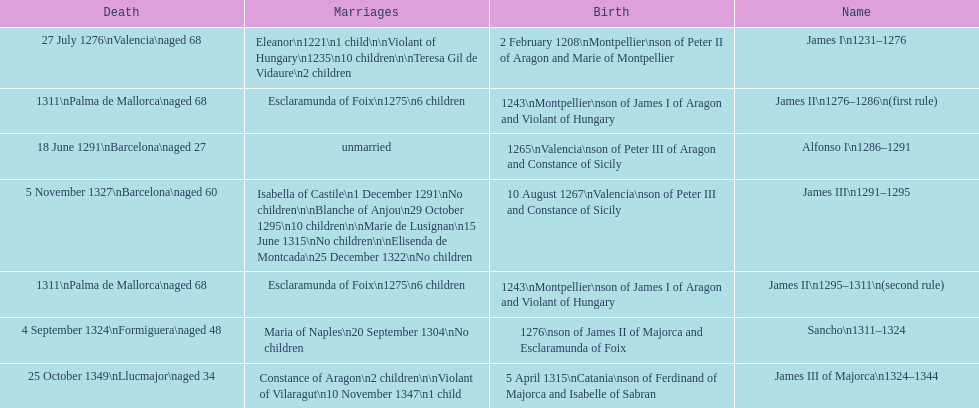Which two monarchs had no children? Alfonso I, Sancho. Could you parse the entire table as a dict? {'header': ['Death', 'Marriages', 'Birth', 'Name'], 'rows': [['27 July 1276\\nValencia\\naged 68', 'Eleanor\\n1221\\n1 child\\n\\nViolant of Hungary\\n1235\\n10 children\\n\\nTeresa Gil de Vidaure\\n2 children', '2 February 1208\\nMontpellier\\nson of Peter II of Aragon and Marie of Montpellier', 'James I\\n1231–1276'], ['1311\\nPalma de Mallorca\\naged 68', 'Esclaramunda of Foix\\n1275\\n6 children', '1243\\nMontpellier\\nson of James I of Aragon and Violant of Hungary', 'James II\\n1276–1286\\n(first rule)'], ['18 June 1291\\nBarcelona\\naged 27', 'unmarried', '1265\\nValencia\\nson of Peter III of Aragon and Constance of Sicily', 'Alfonso I\\n1286–1291'], ['5 November 1327\\nBarcelona\\naged 60', 'Isabella of Castile\\n1 December 1291\\nNo children\\n\\nBlanche of Anjou\\n29 October 1295\\n10 children\\n\\nMarie de Lusignan\\n15 June 1315\\nNo children\\n\\nElisenda de Montcada\\n25 December 1322\\nNo children', '10 August 1267\\nValencia\\nson of Peter III and Constance of Sicily', 'James III\\n1291–1295'], ['1311\\nPalma de Mallorca\\naged 68', 'Esclaramunda of Foix\\n1275\\n6 children', '1243\\nMontpellier\\nson of James I of Aragon and Violant of Hungary', 'James II\\n1295–1311\\n(second rule)'], ['4 September 1324\\nFormiguera\\naged 48', 'Maria of Naples\\n20 September 1304\\nNo children', '1276\\nson of James II of Majorca and Esclaramunda of Foix', 'Sancho\\n1311–1324'], ['25 October 1349\\nLlucmajor\\naged 34', 'Constance of Aragon\\n2 children\\n\\nViolant of Vilaragut\\n10 November 1347\\n1 child', '5 April 1315\\nCatania\\nson of Ferdinand of Majorca and Isabelle of Sabran', 'James III of Majorca\\n1324–1344']]} 